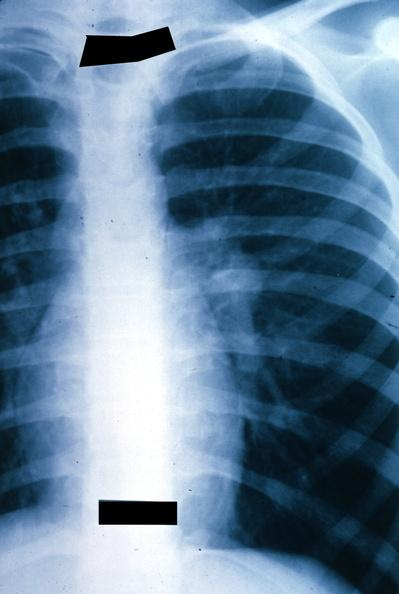how is x-ray chest left hilar mass tumor in hilar?
Answer the question using a single word or phrase. Node 